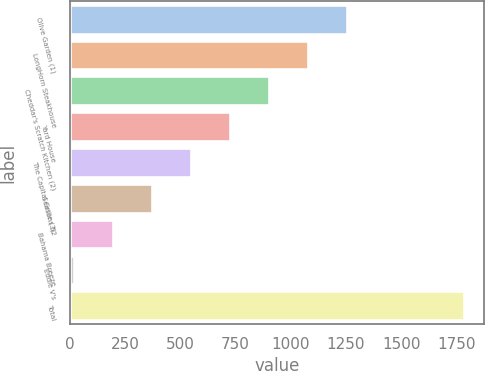Convert chart to OTSL. <chart><loc_0><loc_0><loc_500><loc_500><bar_chart><fcel>Olive Garden (1)<fcel>LongHorn Steakhouse<fcel>Cheddar's Scratch Kitchen (2)<fcel>Yard House<fcel>The Capital Grille (3)<fcel>Seasons 52<fcel>Bahama Breeze<fcel>Eddie V's<fcel>Total<nl><fcel>1255.8<fcel>1079.4<fcel>903<fcel>726.6<fcel>550.2<fcel>373.8<fcel>197.4<fcel>21<fcel>1785<nl></chart> 